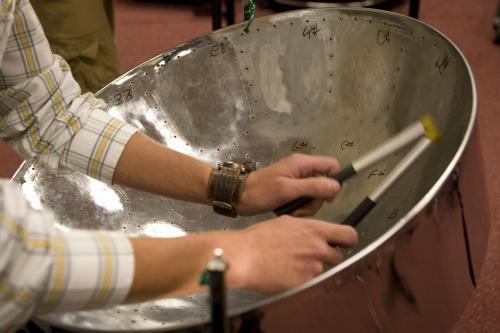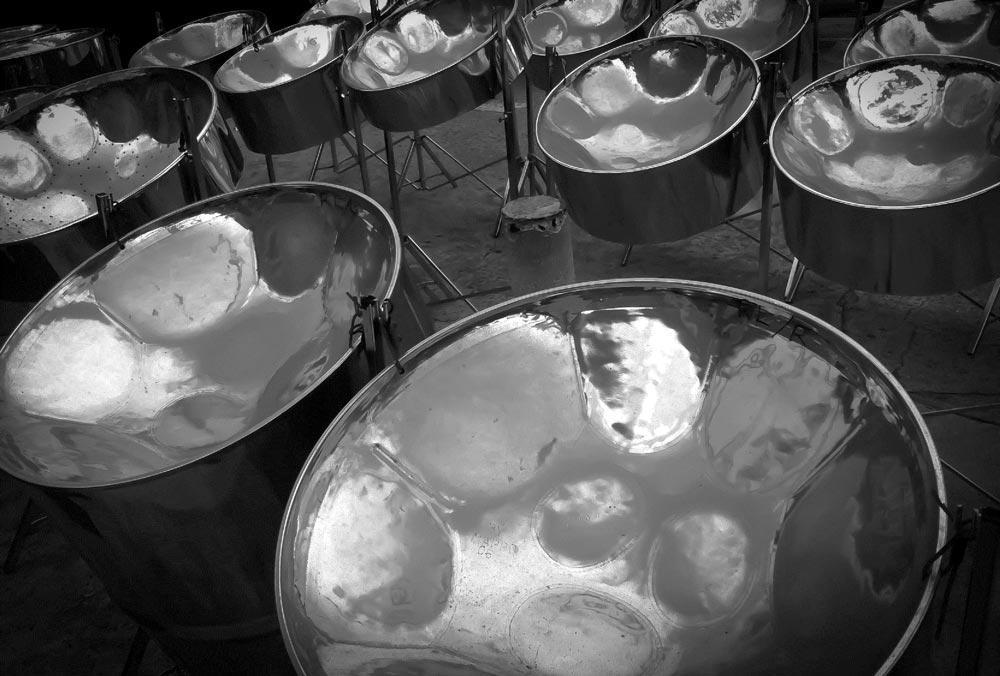The first image is the image on the left, the second image is the image on the right. For the images displayed, is the sentence "In exactly one image someone is playing steel drums." factually correct? Answer yes or no. Yes. The first image is the image on the left, the second image is the image on the right. Examine the images to the left and right. Is the description "One image features at least one steel drum with a concave hammered-look bowl, and the other image shows one person holding two drum sticks inside one drum's bowl." accurate? Answer yes or no. Yes. 